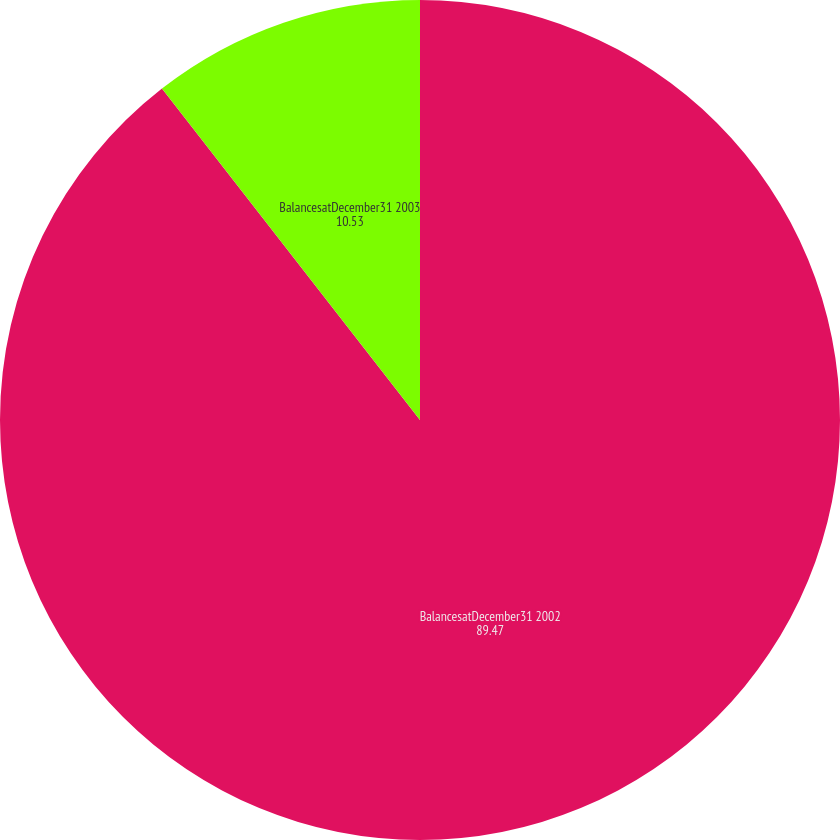<chart> <loc_0><loc_0><loc_500><loc_500><pie_chart><fcel>BalancesatDecember31 2002<fcel>BalancesatDecember31 2003<nl><fcel>89.47%<fcel>10.53%<nl></chart> 